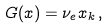Convert formula to latex. <formula><loc_0><loc_0><loc_500><loc_500>G ( { x } ) = \nu _ { e } x _ { k } \, ,</formula> 